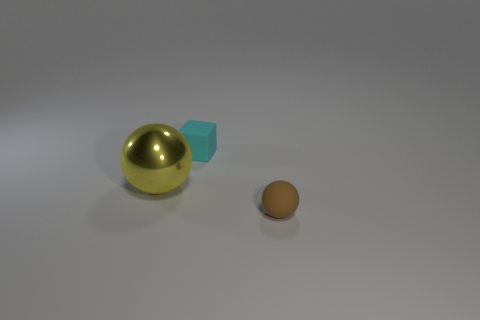Add 3 yellow objects. How many objects exist? 6 Subtract all cubes. How many objects are left? 2 Add 3 big purple shiny cylinders. How many big purple shiny cylinders exist? 3 Subtract 1 yellow spheres. How many objects are left? 2 Subtract all yellow metal spheres. Subtract all small brown things. How many objects are left? 1 Add 2 rubber objects. How many rubber objects are left? 4 